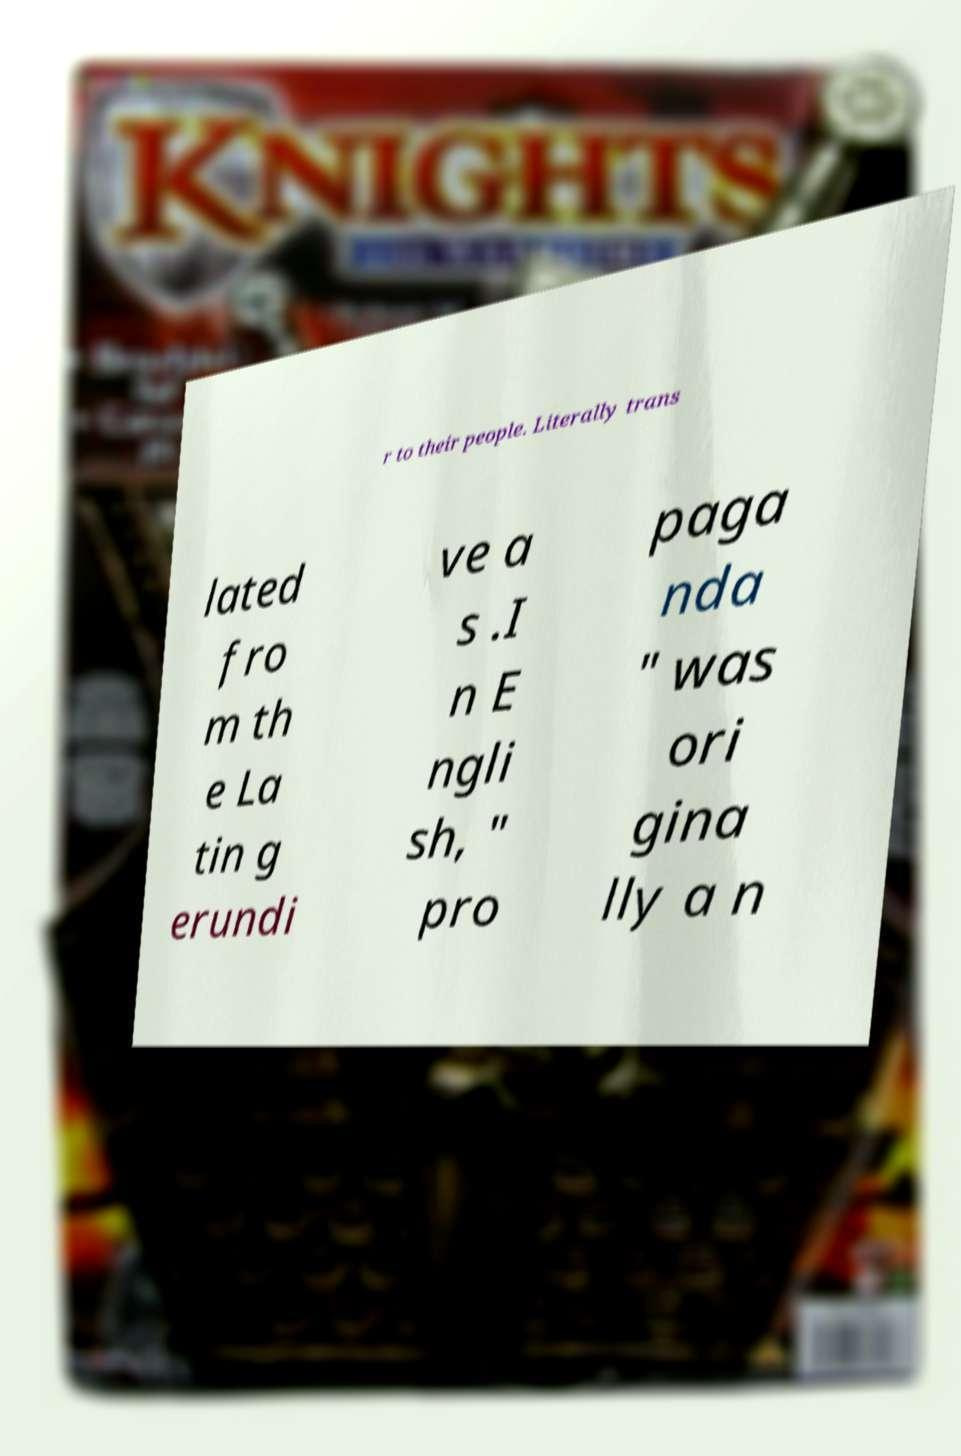For documentation purposes, I need the text within this image transcribed. Could you provide that? r to their people. Literally trans lated fro m th e La tin g erundi ve a s .I n E ngli sh, " pro paga nda " was ori gina lly a n 